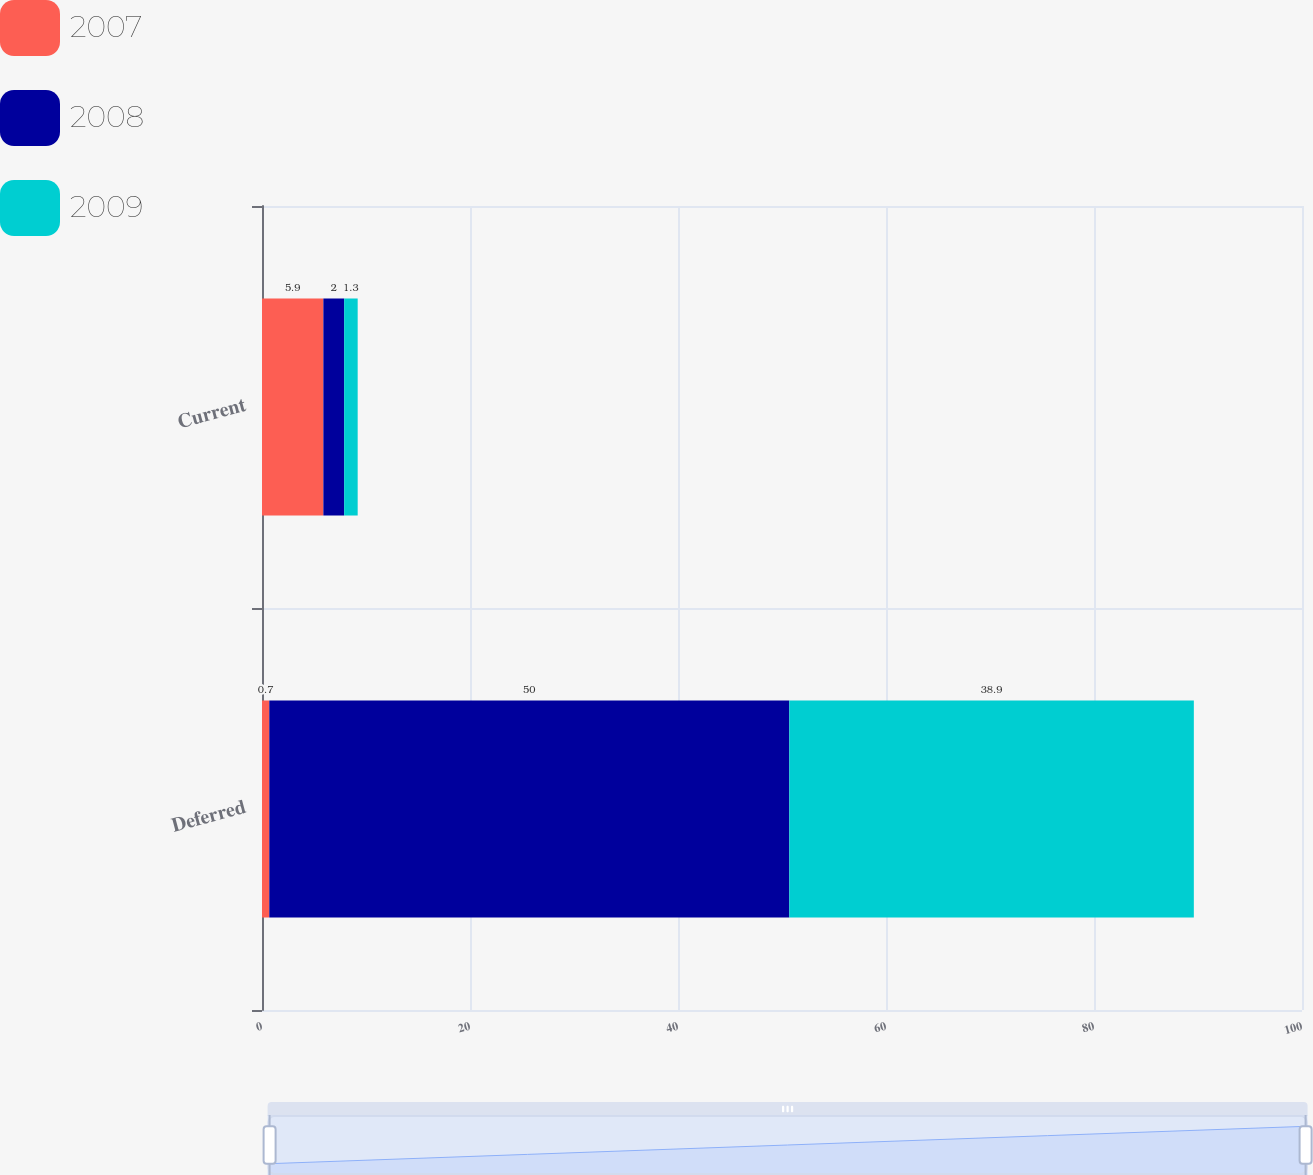Convert chart to OTSL. <chart><loc_0><loc_0><loc_500><loc_500><stacked_bar_chart><ecel><fcel>Deferred<fcel>Current<nl><fcel>2007<fcel>0.7<fcel>5.9<nl><fcel>2008<fcel>50<fcel>2<nl><fcel>2009<fcel>38.9<fcel>1.3<nl></chart> 